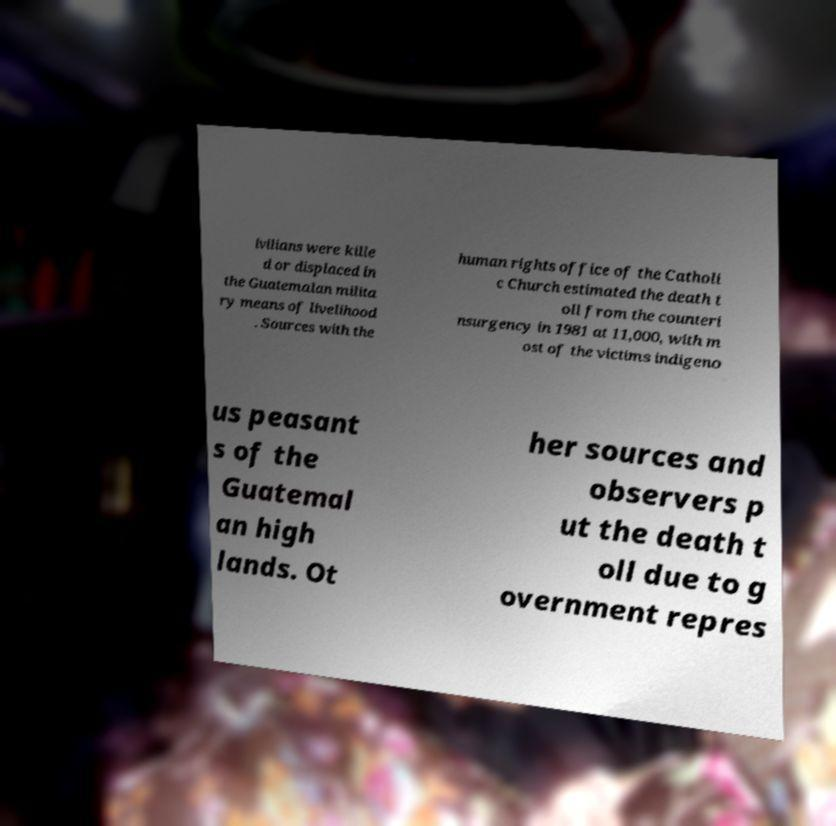Please identify and transcribe the text found in this image. ivilians were kille d or displaced in the Guatemalan milita ry means of livelihood . Sources with the human rights office of the Catholi c Church estimated the death t oll from the counteri nsurgency in 1981 at 11,000, with m ost of the victims indigeno us peasant s of the Guatemal an high lands. Ot her sources and observers p ut the death t oll due to g overnment repres 